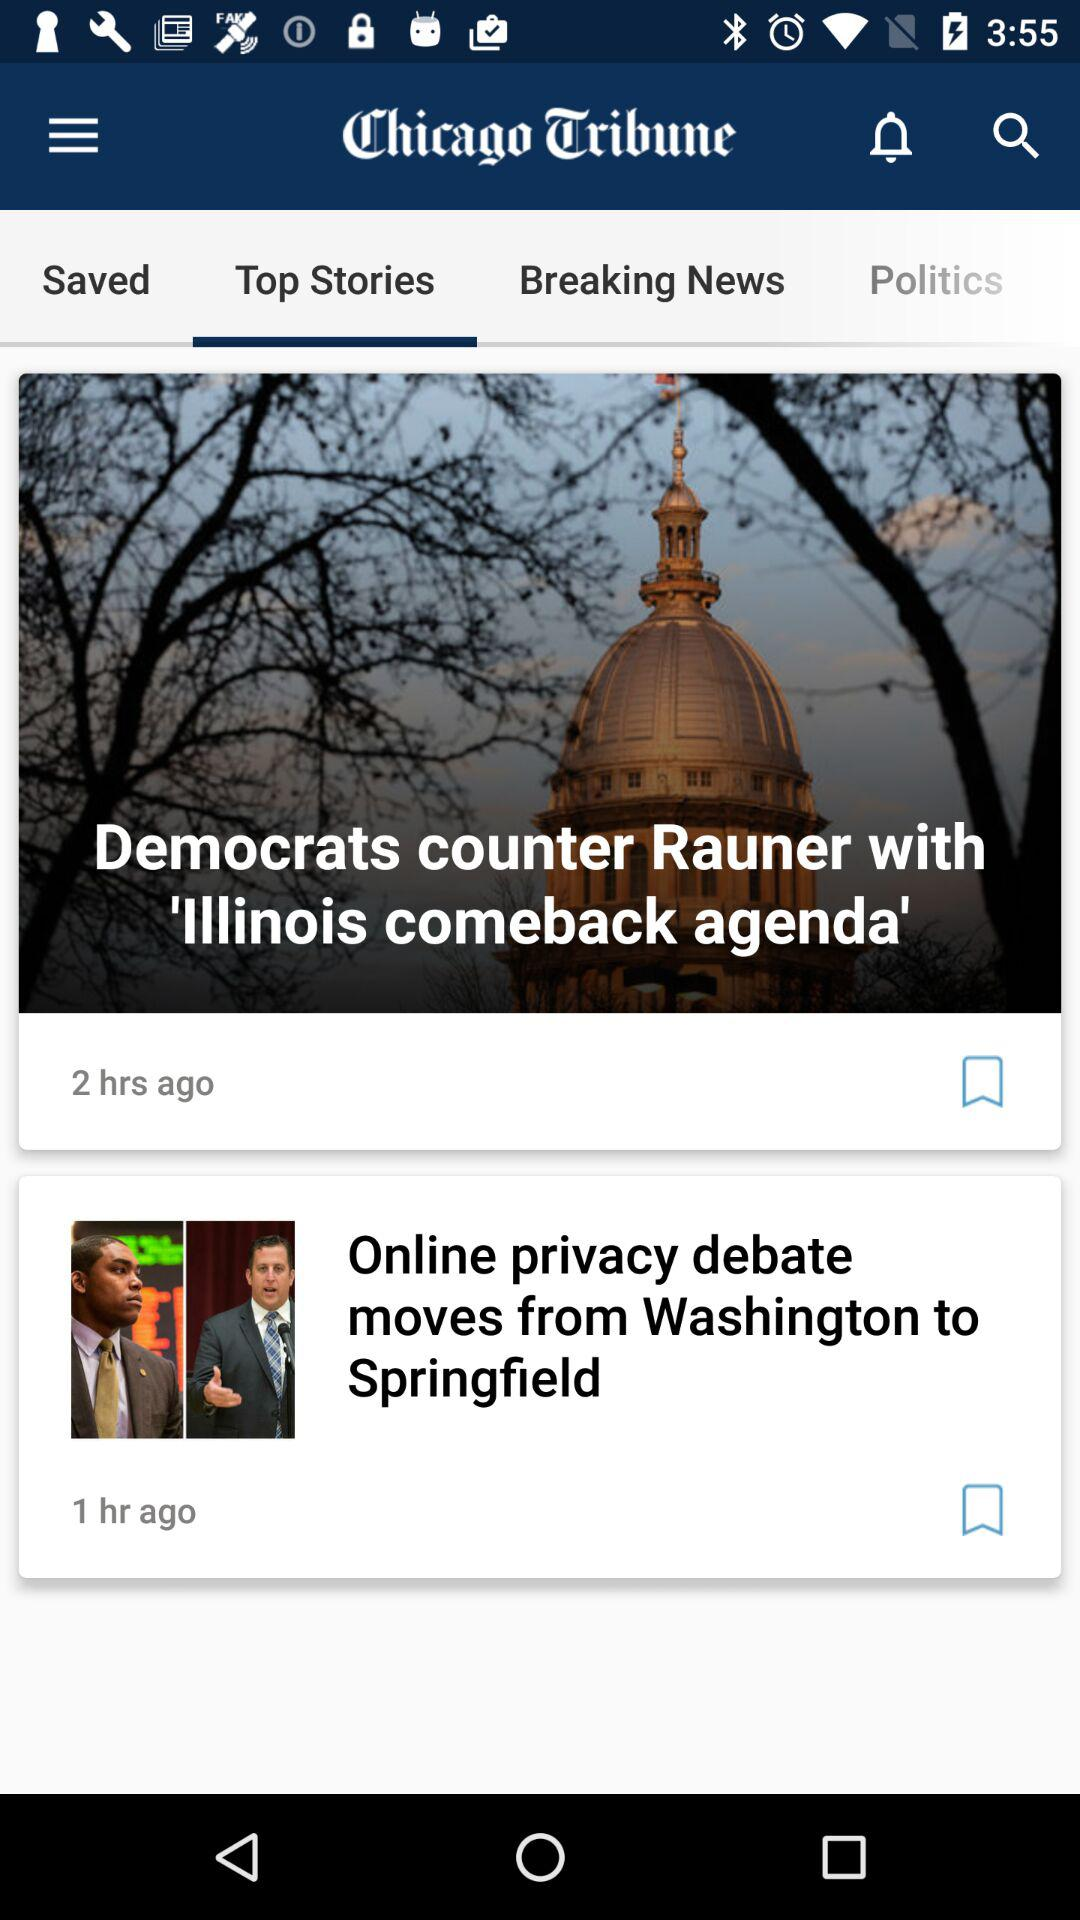How many more hours ago was the first article published than the second article?
Answer the question using a single word or phrase. 1 